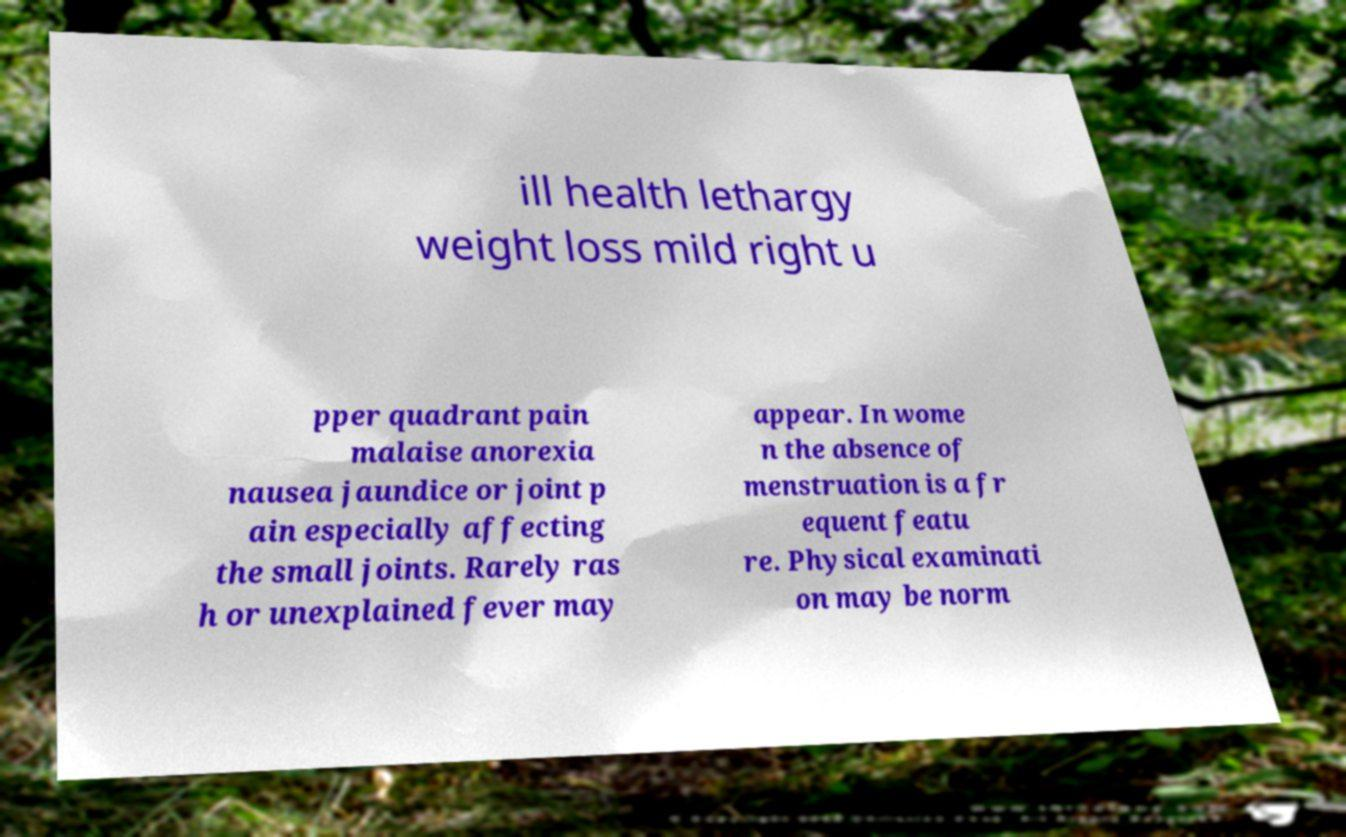Can you read and provide the text displayed in the image?This photo seems to have some interesting text. Can you extract and type it out for me? ill health lethargy weight loss mild right u pper quadrant pain malaise anorexia nausea jaundice or joint p ain especially affecting the small joints. Rarely ras h or unexplained fever may appear. In wome n the absence of menstruation is a fr equent featu re. Physical examinati on may be norm 